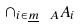<formula> <loc_0><loc_0><loc_500><loc_500>\cap _ { i \in \underline { m } \ A } A _ { i }</formula> 